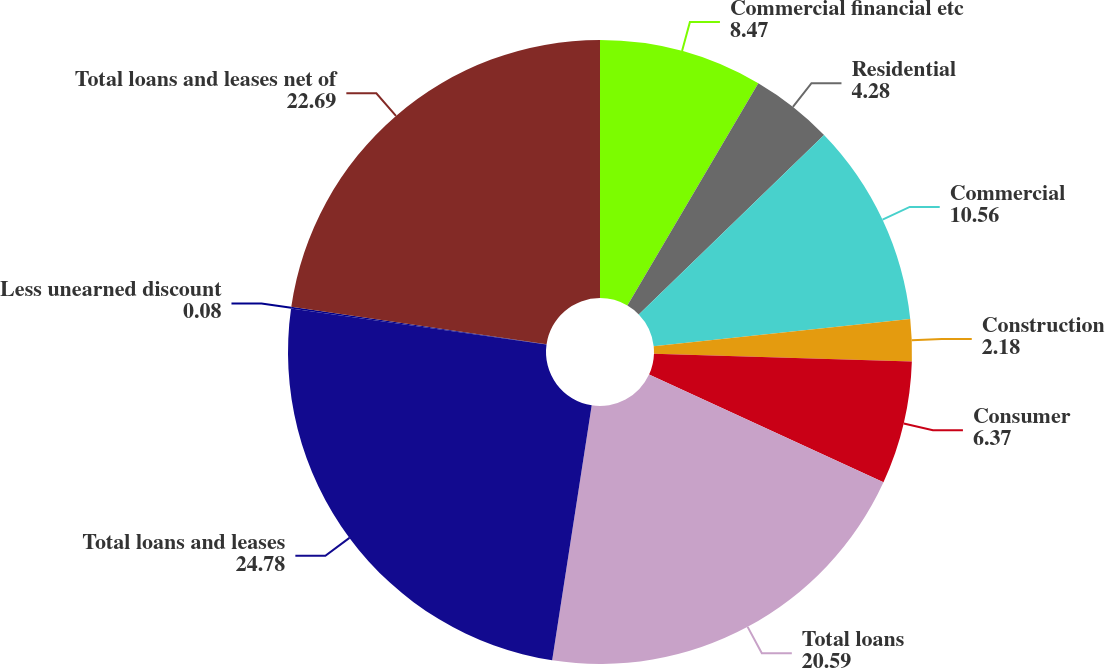Convert chart. <chart><loc_0><loc_0><loc_500><loc_500><pie_chart><fcel>Commercial financial etc<fcel>Residential<fcel>Commercial<fcel>Construction<fcel>Consumer<fcel>Total loans<fcel>Total loans and leases<fcel>Less unearned discount<fcel>Total loans and leases net of<nl><fcel>8.47%<fcel>4.28%<fcel>10.56%<fcel>2.18%<fcel>6.37%<fcel>20.59%<fcel>24.78%<fcel>0.08%<fcel>22.69%<nl></chart> 